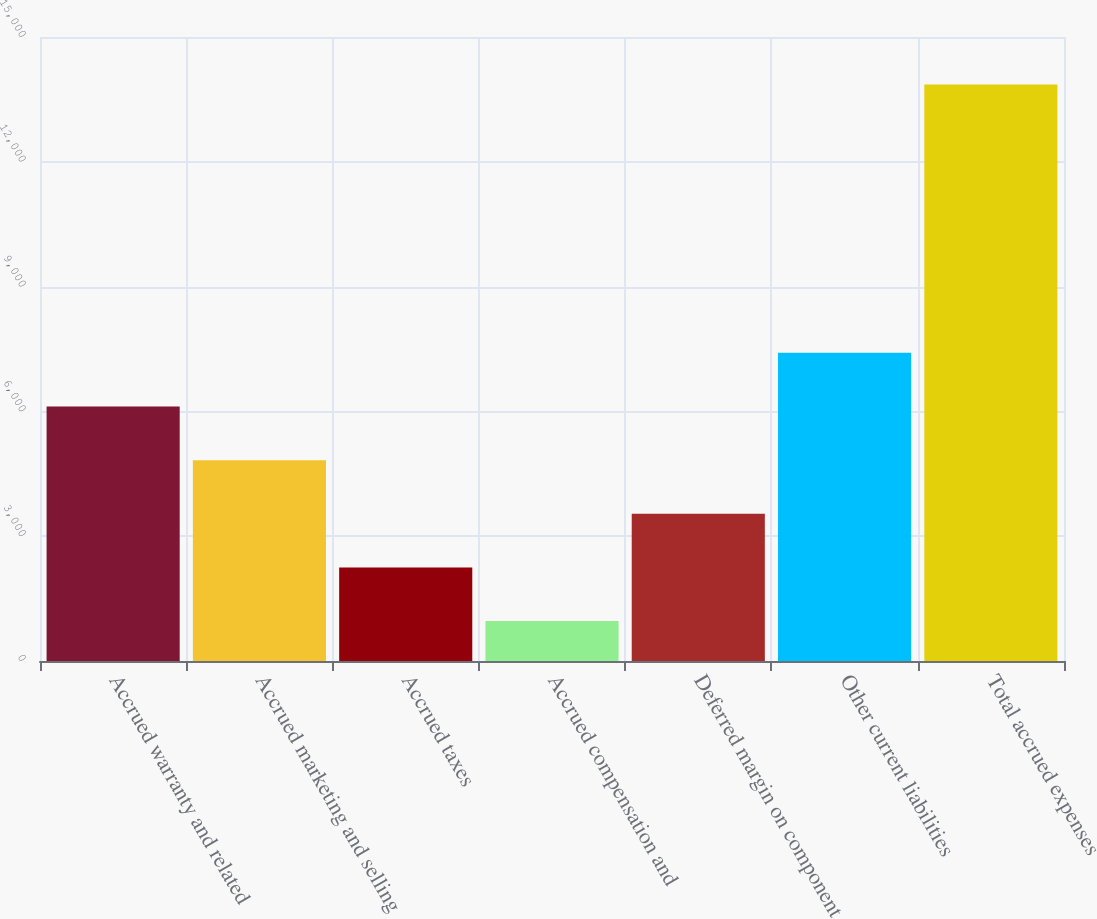Convert chart. <chart><loc_0><loc_0><loc_500><loc_500><bar_chart><fcel>Accrued warranty and related<fcel>Accrued marketing and selling<fcel>Accrued taxes<fcel>Accrued compensation and<fcel>Deferred margin on component<fcel>Other current liabilities<fcel>Total accrued expenses<nl><fcel>6117.8<fcel>4828.1<fcel>2248.7<fcel>959<fcel>3538.4<fcel>7407.5<fcel>13856<nl></chart> 